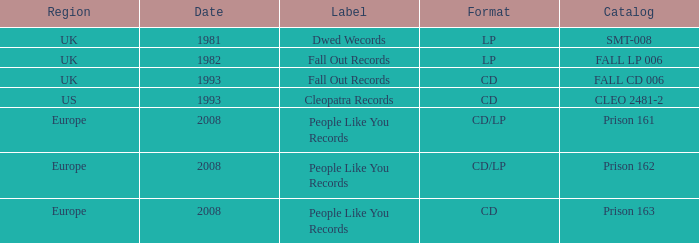Which label possesses a date earlier than 2008 and a catalog corresponding to fall cd 006? Fall Out Records. 